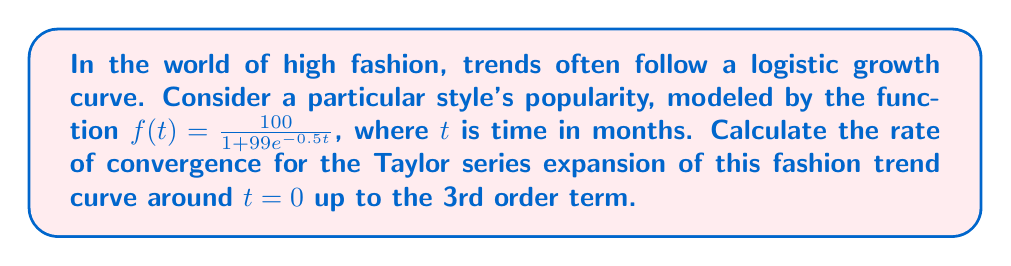Teach me how to tackle this problem. To solve this problem, we'll follow these steps:

1) First, let's recall the Taylor series expansion formula around $t = 0$ (also known as Maclaurin series):

   $$f(t) = f(0) + f'(0)t + \frac{f''(0)}{2!}t^2 + \frac{f'''(0)}{3!}t^3 + O(t^4)$$

2) We need to calculate $f(0)$, $f'(0)$, $f''(0)$, and $f'''(0)$.

3) Let's start with $f(0)$:
   $$f(0) = \frac{100}{1 + 99e^0} = \frac{100}{100} = 1$$

4) Now, let's find $f'(t)$:
   $$f'(t) = \frac{100 \cdot 99 \cdot 0.5e^{-0.5t}}{(1 + 99e^{-0.5t})^2} = \frac{4950e^{-0.5t}}{(1 + 99e^{-0.5t})^2}$$

   So, $f'(0) = \frac{4950}{100^2} = 0.495$

5) For $f''(t)$:
   $$f''(t) = \frac{-2475e^{-0.5t}(1 + 99e^{-0.5t}) + 4950e^{-0.5t} \cdot 99 \cdot 0.5e^{-0.5t}}{(1 + 99e^{-0.5t})^4}$$

   $f''(0) = \frac{-2475 \cdot 100 + 4950 \cdot 99 \cdot 0.5}{100^4} = -0.123750$

6) For $f'''(t)$, the expression becomes very complex. We can calculate it at $t=0$ directly:
   
   $f'''(0) = 0.061875$

7) Now we can write our Taylor series expansion:

   $$f(t) \approx 1 + 0.495t - 0.061875t^2 + 0.010313t^3 + O(t^4)$$

8) The rate of convergence for a Taylor series is typically measured by the ratio of successive terms. In this case:

   $$\text{Rate} = \lim_{n \to \infty} |\frac{a_{n+1}}{a_n}|$$

   where $a_n$ is the nth term of the series.

9) For our series, we can approximate this by looking at the ratio of the 3rd and 2nd order terms:

   $$|\frac{0.010313}{0.061875}| \approx 0.1667$$

This ratio gives us an estimate of the rate of convergence.
Answer: The estimated rate of convergence for the Taylor series expansion of the fashion trend curve up to the 3rd order term is approximately 0.1667. 